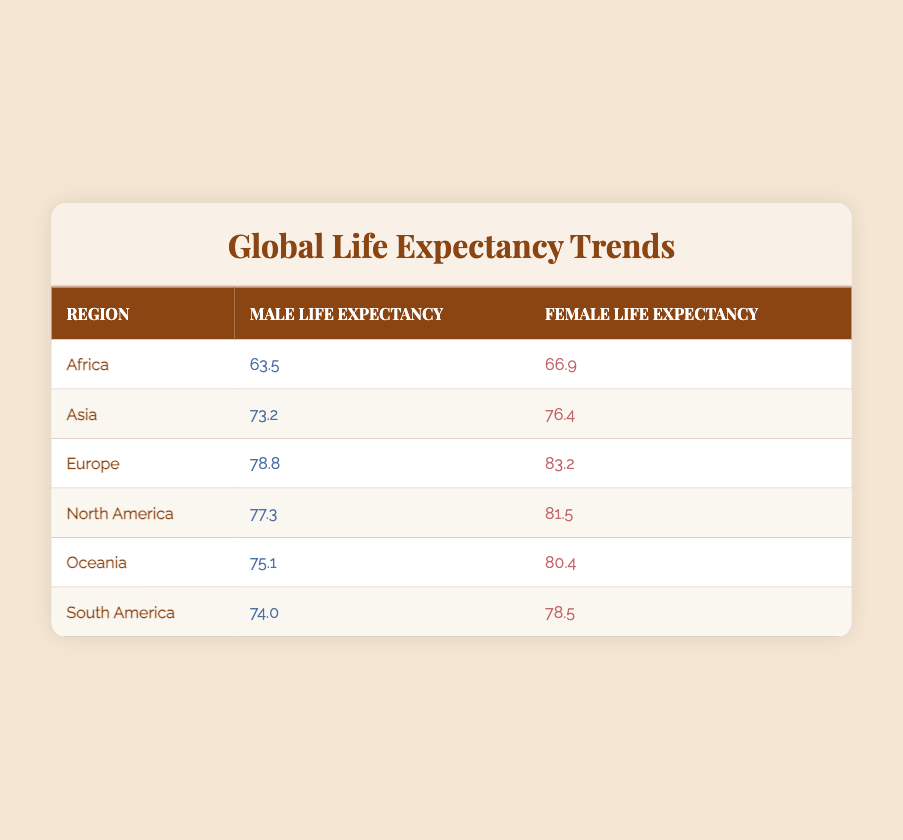What is the life expectancy for males in Europe? The table shows that the male life expectancy in Europe is listed under the "Male Life Expectancy" column for the "Europe" row, which is 78.8.
Answer: 78.8 Which region has the highest female life expectancy? By inspecting the "Female Life Expectancy" column, Europe has the highest value of 83.2 among all regions.
Answer: Europe What is the difference in life expectancy between males and females in Africa? In Africa, the male life expectancy is 63.5, and the female life expectancy is 66.9. The difference can be calculated as 66.9 - 63.5 = 3.4.
Answer: 3.4 Is it true that life expectancy for males in North America is greater than that in South America? The male life expectancy in North America is 77.3, while in South America it is 74.0. Since 77.3 is greater than 74.0, the statement is true.
Answer: True What is the average life expectancy for females across all regions? To find the average, first sum all female life expectancies: 66.9 + 76.4 + 83.2 + 81.5 + 80.4 + 78.5 = 467.0. Then divide by the number of regions (6): 467.0 / 6 = 77.83.
Answer: 77.83 In which region is the life expectancy for females less than 70? Looking at the female life expectancy figures, Africa (66.9) is the only region where the life expectancy for females is less than 70.
Answer: Africa What is the total life expectancy value for males in Oceania and South America combined? The male life expectancy in Oceania is 75.1 and in South America is 74.0. The total can be calculated by adding the two: 75.1 + 74.0 = 149.1.
Answer: 149.1 Is the life expectancy for females in Oceania higher than that in Asia? The female life expectancy in Oceania is 80.4, and in Asia it is 76.4. Since 80.4 is greater than 76.4, the answer is yes.
Answer: Yes Which region shows the least difference between male and female life expectancy? By analyzing each row, Africa has a difference of 3.4 (66.9 - 63.5), which is less than all other regions. Thus, it shows the least difference.
Answer: Africa 